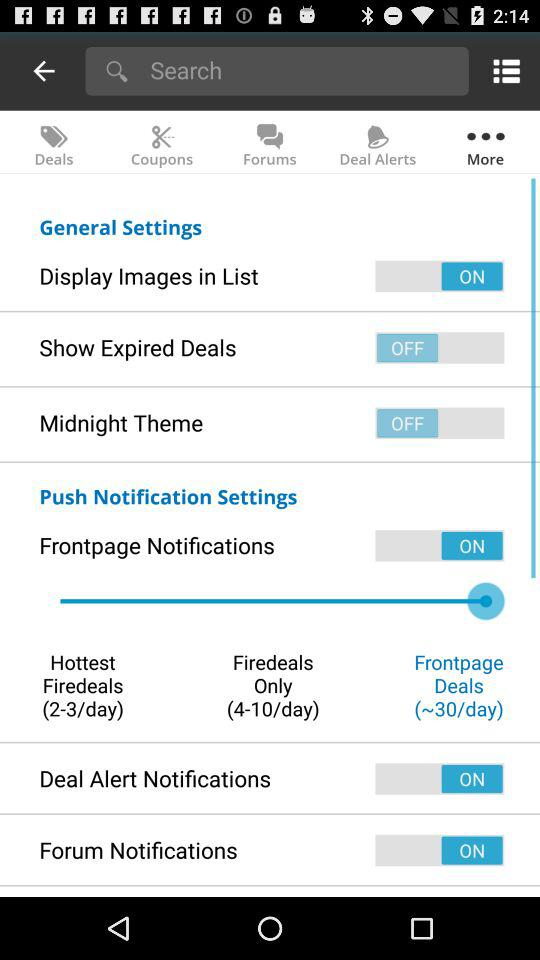Which settings are "switched off"? The settings are "Show Expired Deals" and "Midnight Theme". 